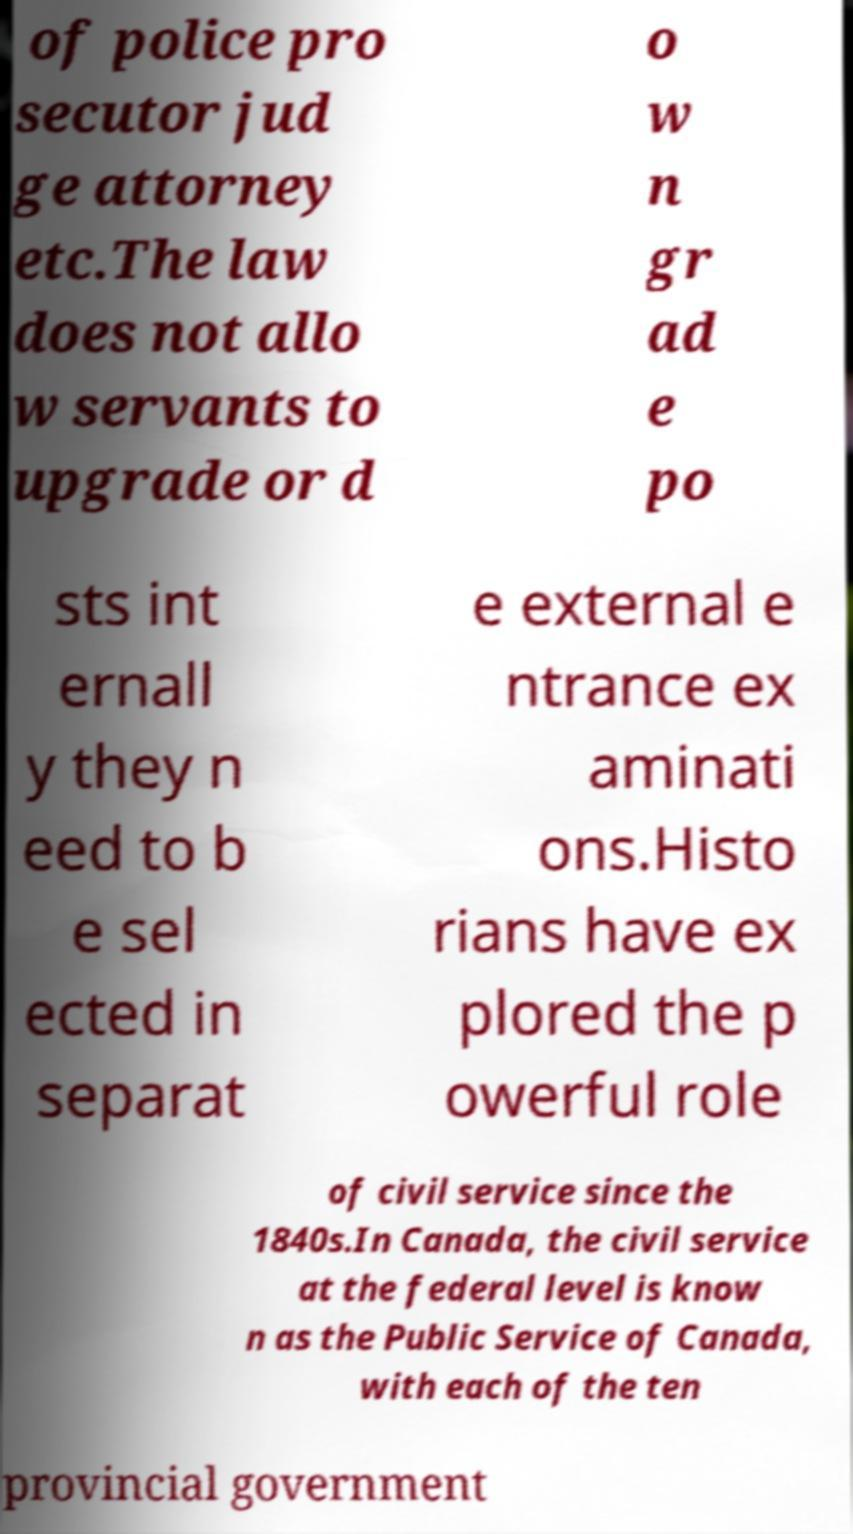For documentation purposes, I need the text within this image transcribed. Could you provide that? of police pro secutor jud ge attorney etc.The law does not allo w servants to upgrade or d o w n gr ad e po sts int ernall y they n eed to b e sel ected in separat e external e ntrance ex aminati ons.Histo rians have ex plored the p owerful role of civil service since the 1840s.In Canada, the civil service at the federal level is know n as the Public Service of Canada, with each of the ten provincial government 